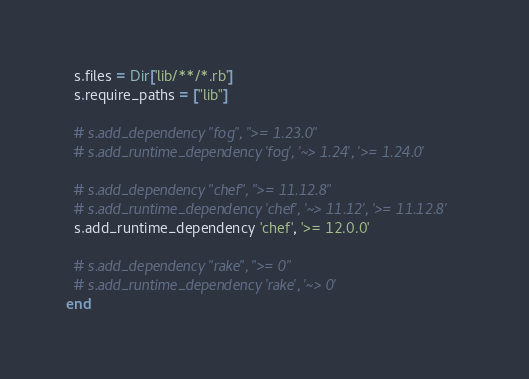<code> <loc_0><loc_0><loc_500><loc_500><_Ruby_>  s.files = Dir['lib/**/*.rb']
  s.require_paths = ["lib"]

  # s.add_dependency "fog", ">= 1.23.0"
  # s.add_runtime_dependency 'fog', '~> 1.24', '>= 1.24.0'

  # s.add_dependency "chef", ">= 11.12.8"
  # s.add_runtime_dependency 'chef', '~> 11.12', '>= 11.12.8'
  s.add_runtime_dependency 'chef', '>= 12.0.0'

  # s.add_dependency "rake", ">= 0"
  # s.add_runtime_dependency 'rake', '~> 0'
end
</code> 